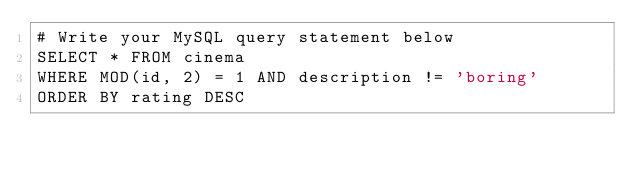Convert code to text. <code><loc_0><loc_0><loc_500><loc_500><_SQL_># Write your MySQL query statement below
SELECT * FROM cinema
WHERE MOD(id, 2) = 1 AND description != 'boring'
ORDER BY rating DESC</code> 